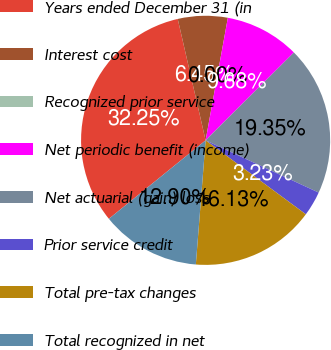Convert chart. <chart><loc_0><loc_0><loc_500><loc_500><pie_chart><fcel>Years ended December 31 (in<fcel>Interest cost<fcel>Recognized prior service<fcel>Net periodic benefit (income)<fcel>Net actuarial (gain) loss<fcel>Prior service credit<fcel>Total pre-tax changes<fcel>Total recognized in net<nl><fcel>32.25%<fcel>6.45%<fcel>0.0%<fcel>9.68%<fcel>19.35%<fcel>3.23%<fcel>16.13%<fcel>12.9%<nl></chart> 